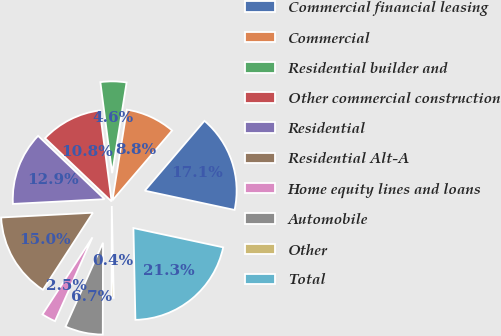<chart> <loc_0><loc_0><loc_500><loc_500><pie_chart><fcel>Commercial financial leasing<fcel>Commercial<fcel>Residential builder and<fcel>Other commercial construction<fcel>Residential<fcel>Residential Alt-A<fcel>Home equity lines and loans<fcel>Automobile<fcel>Other<fcel>Total<nl><fcel>17.11%<fcel>8.75%<fcel>4.56%<fcel>10.84%<fcel>12.93%<fcel>15.02%<fcel>2.47%<fcel>6.65%<fcel>0.38%<fcel>21.29%<nl></chart> 